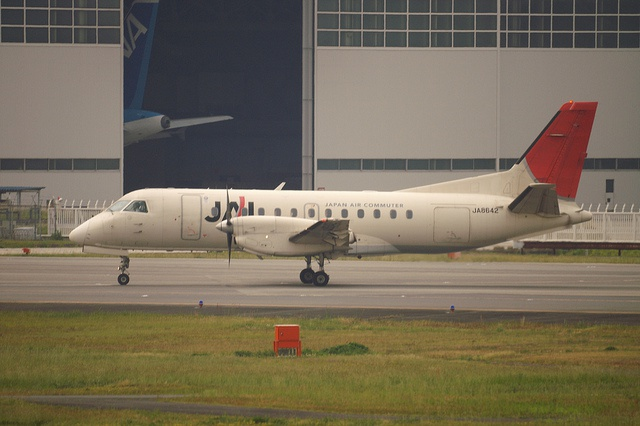Describe the objects in this image and their specific colors. I can see airplane in gray, tan, and beige tones, airplane in gray, blue, and black tones, and people in gray, purple, and black tones in this image. 